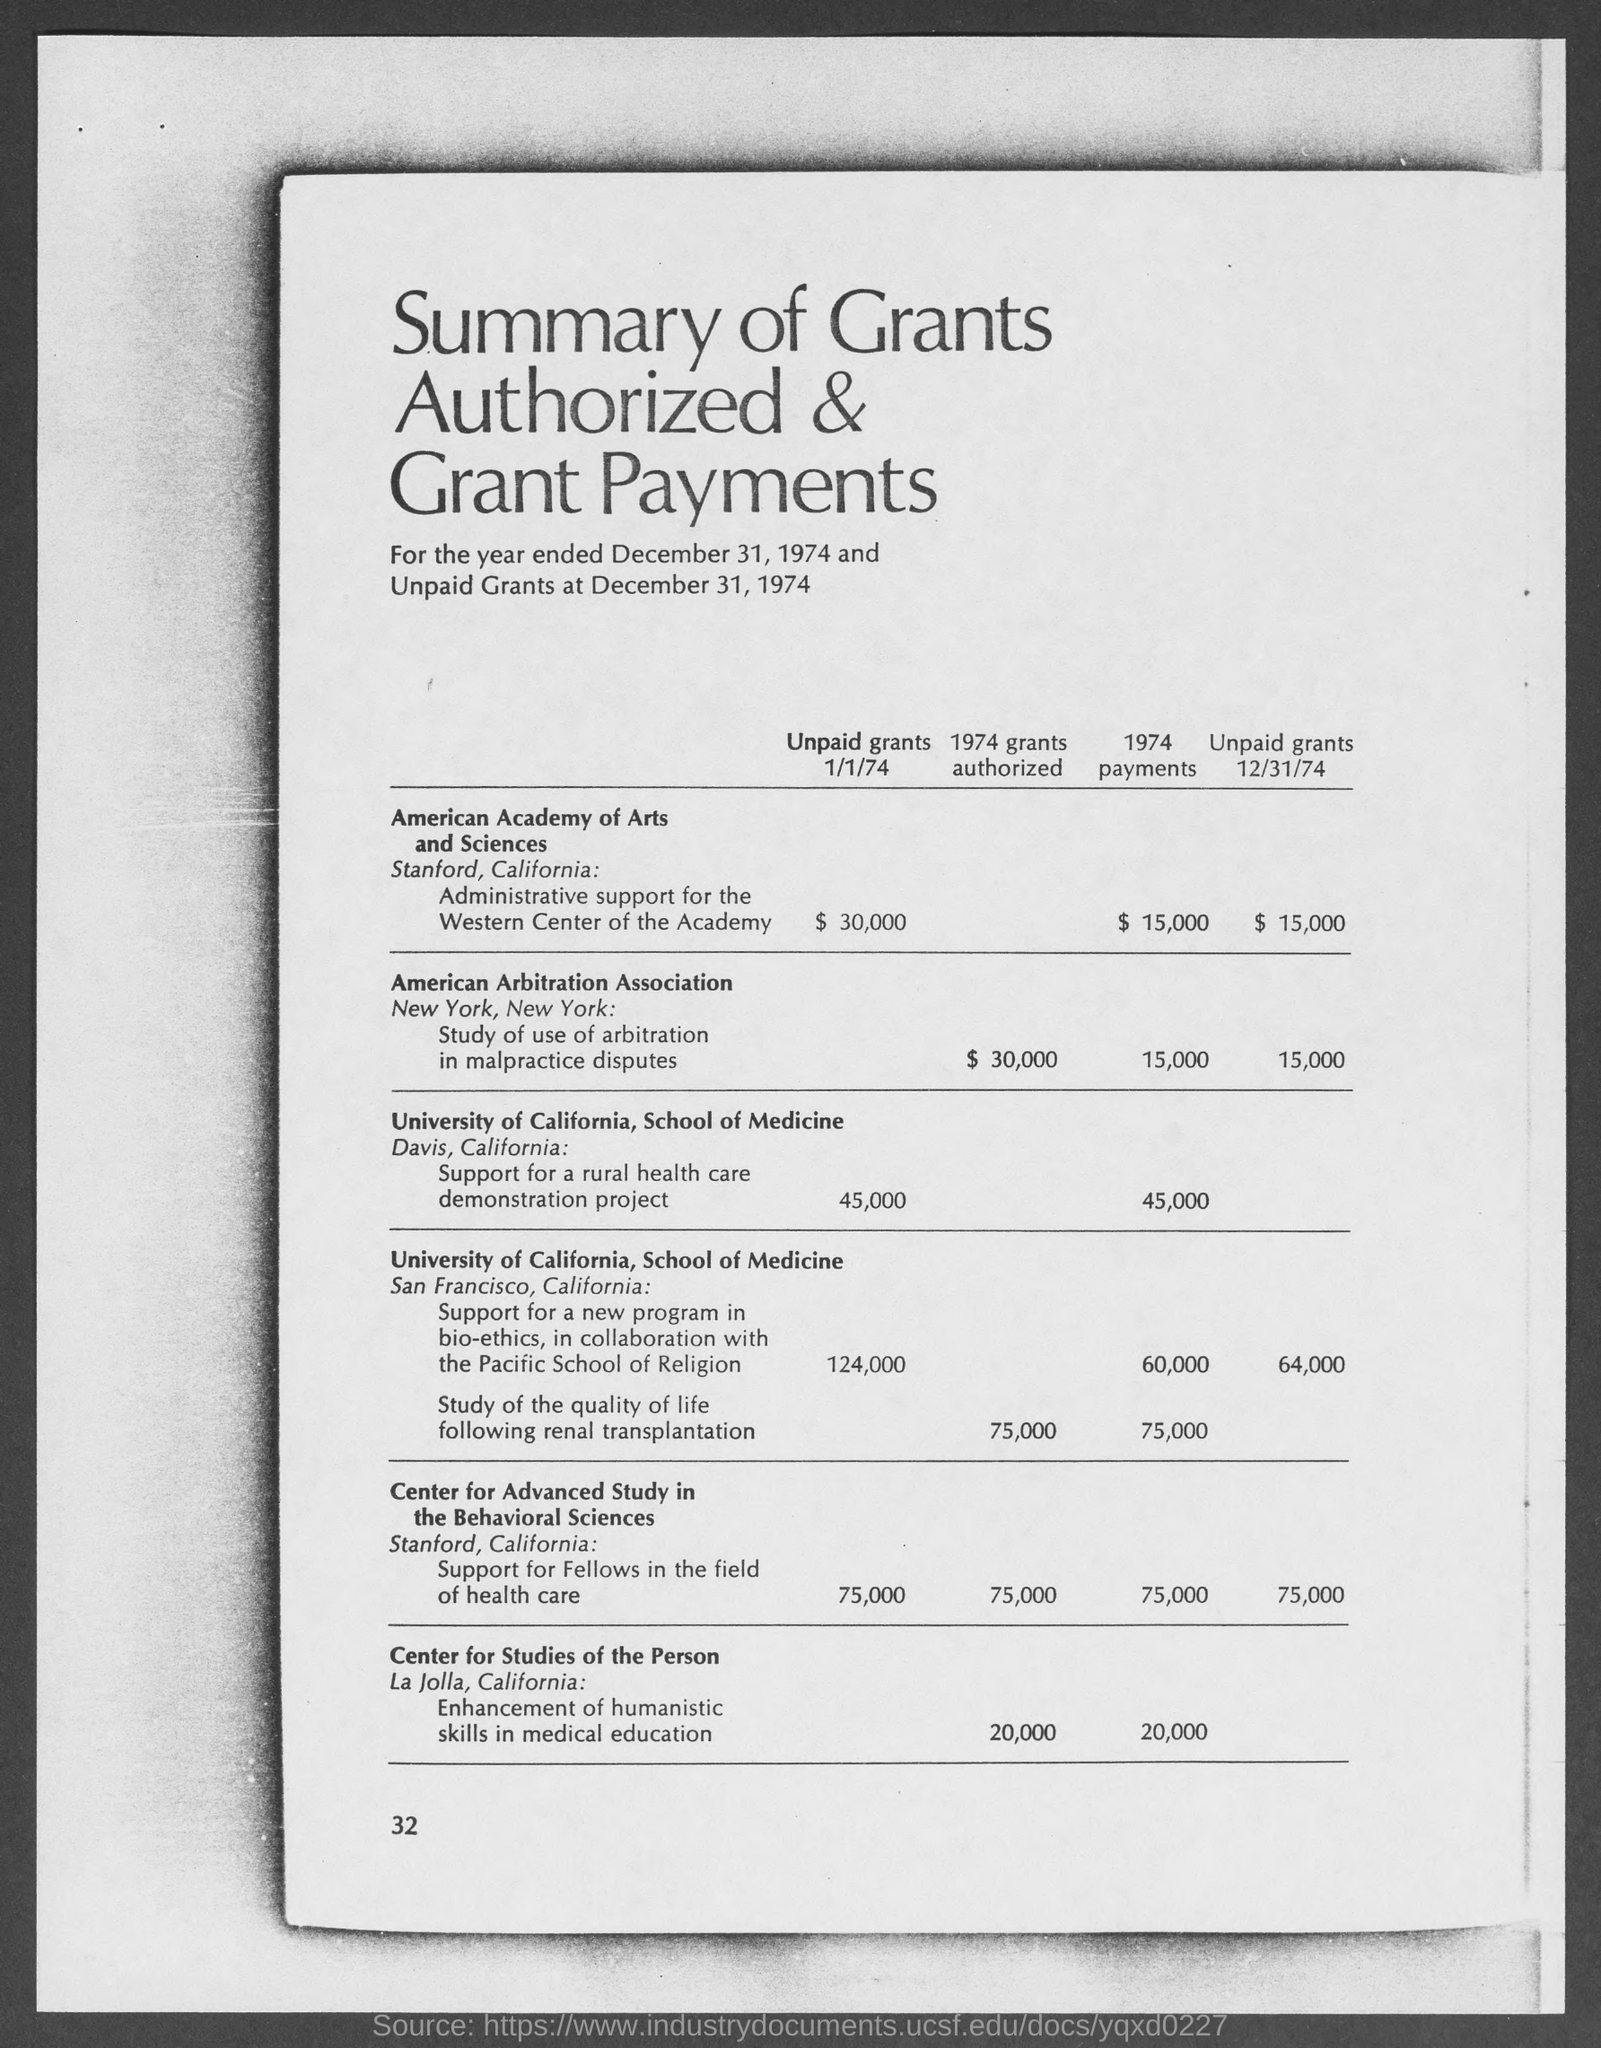What is the page number?
Offer a terse response. 32. What is the value of unpaid grants 12/31/74 by American Arbitration Association in $?
Offer a terse response. 15,000. 